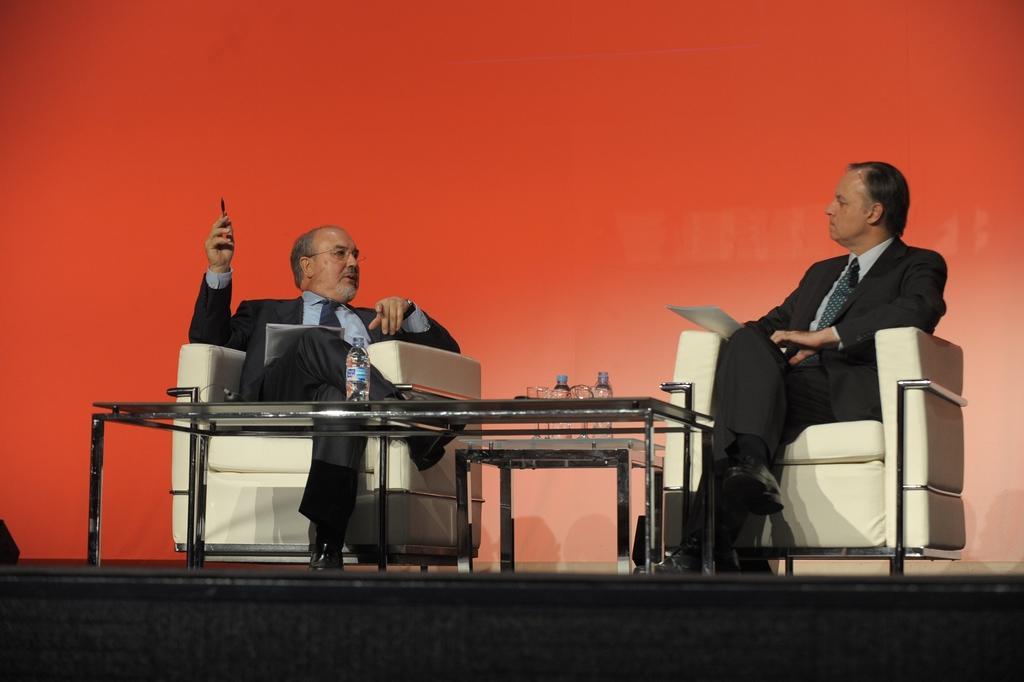Please provide a concise description of this image. In this image there are two persons sitting on couch. On the table there is a water bottle. 